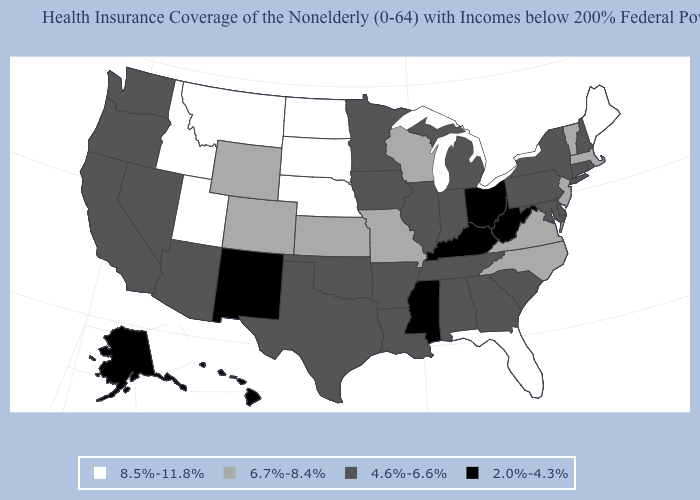Name the states that have a value in the range 4.6%-6.6%?
Keep it brief. Alabama, Arizona, Arkansas, California, Connecticut, Delaware, Georgia, Illinois, Indiana, Iowa, Louisiana, Maryland, Michigan, Minnesota, Nevada, New Hampshire, New York, Oklahoma, Oregon, Pennsylvania, Rhode Island, South Carolina, Tennessee, Texas, Washington. Among the states that border New Mexico , does Oklahoma have the lowest value?
Answer briefly. Yes. What is the value of Indiana?
Give a very brief answer. 4.6%-6.6%. What is the value of Connecticut?
Write a very short answer. 4.6%-6.6%. Does North Dakota have the same value as Tennessee?
Concise answer only. No. Name the states that have a value in the range 8.5%-11.8%?
Concise answer only. Florida, Idaho, Maine, Montana, Nebraska, North Dakota, South Dakota, Utah. Does New Mexico have the lowest value in the USA?
Keep it brief. Yes. What is the value of Michigan?
Keep it brief. 4.6%-6.6%. What is the value of Hawaii?
Write a very short answer. 2.0%-4.3%. Name the states that have a value in the range 6.7%-8.4%?
Write a very short answer. Colorado, Kansas, Massachusetts, Missouri, New Jersey, North Carolina, Vermont, Virginia, Wisconsin, Wyoming. Name the states that have a value in the range 8.5%-11.8%?
Give a very brief answer. Florida, Idaho, Maine, Montana, Nebraska, North Dakota, South Dakota, Utah. Does Florida have the highest value in the USA?
Quick response, please. Yes. Does Missouri have a higher value than New Jersey?
Short answer required. No. What is the value of Kansas?
Write a very short answer. 6.7%-8.4%. Name the states that have a value in the range 2.0%-4.3%?
Answer briefly. Alaska, Hawaii, Kentucky, Mississippi, New Mexico, Ohio, West Virginia. 